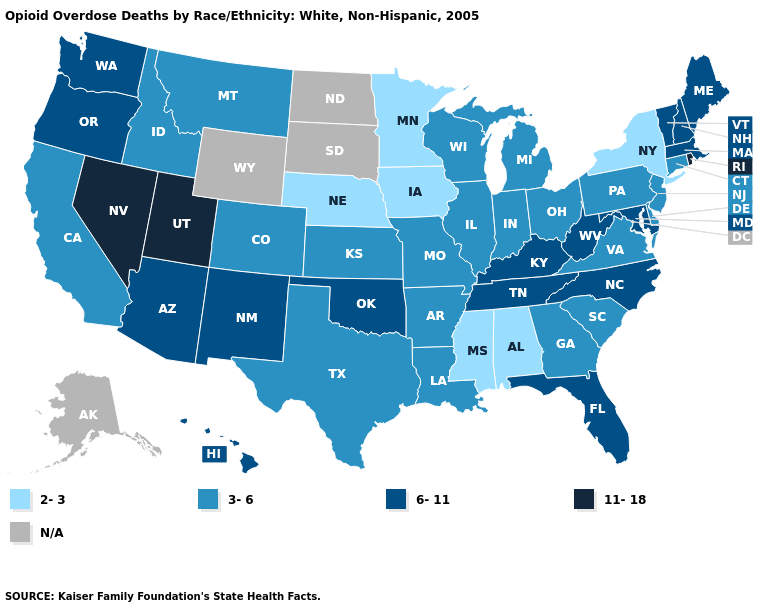Does the map have missing data?
Answer briefly. Yes. Which states hav the highest value in the West?
Short answer required. Nevada, Utah. Among the states that border Ohio , does Indiana have the lowest value?
Quick response, please. Yes. What is the highest value in the USA?
Be succinct. 11-18. What is the value of Wisconsin?
Answer briefly. 3-6. Does the map have missing data?
Answer briefly. Yes. Does Rhode Island have the highest value in the USA?
Be succinct. Yes. What is the value of Alabama?
Short answer required. 2-3. Among the states that border Illinois , which have the lowest value?
Quick response, please. Iowa. Which states have the lowest value in the South?
Write a very short answer. Alabama, Mississippi. Name the states that have a value in the range N/A?
Keep it brief. Alaska, North Dakota, South Dakota, Wyoming. What is the value of Kentucky?
Give a very brief answer. 6-11. Name the states that have a value in the range N/A?
Short answer required. Alaska, North Dakota, South Dakota, Wyoming. What is the highest value in the USA?
Short answer required. 11-18. Does Mississippi have the lowest value in the USA?
Answer briefly. Yes. 